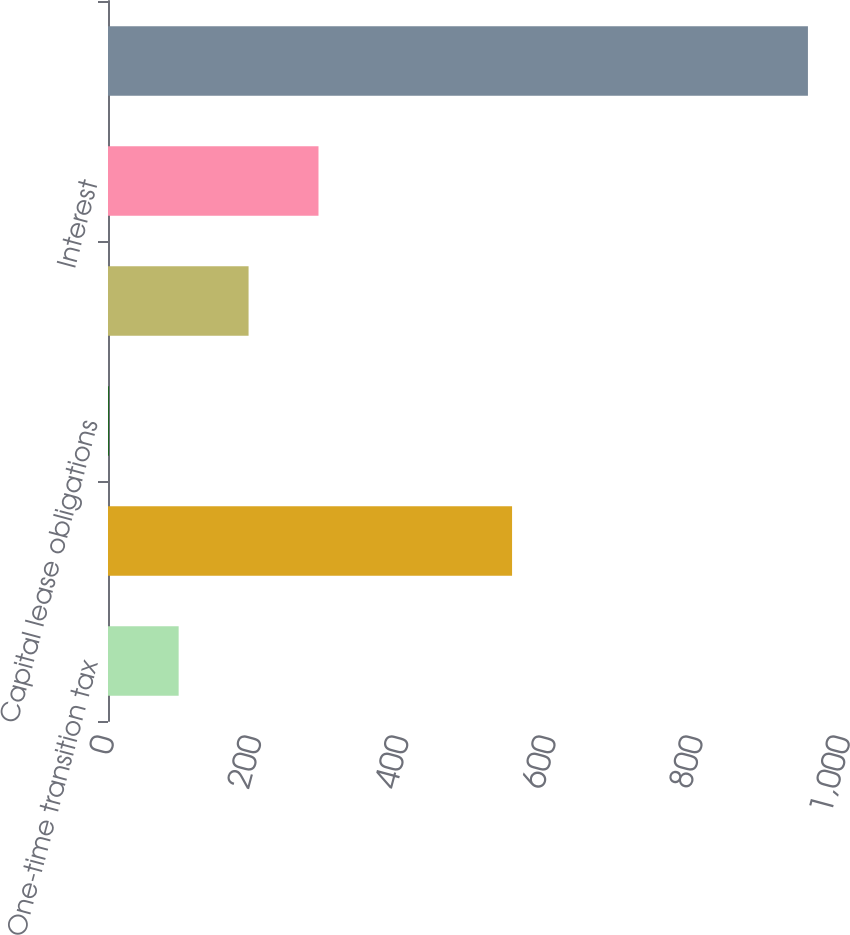<chart> <loc_0><loc_0><loc_500><loc_500><bar_chart><fcel>One-time transition tax<fcel>Long-term debt<fcel>Capital lease obligations<fcel>Operating leases<fcel>Interest<fcel>Total<nl><fcel>96<fcel>549<fcel>1<fcel>191<fcel>286<fcel>951<nl></chart> 